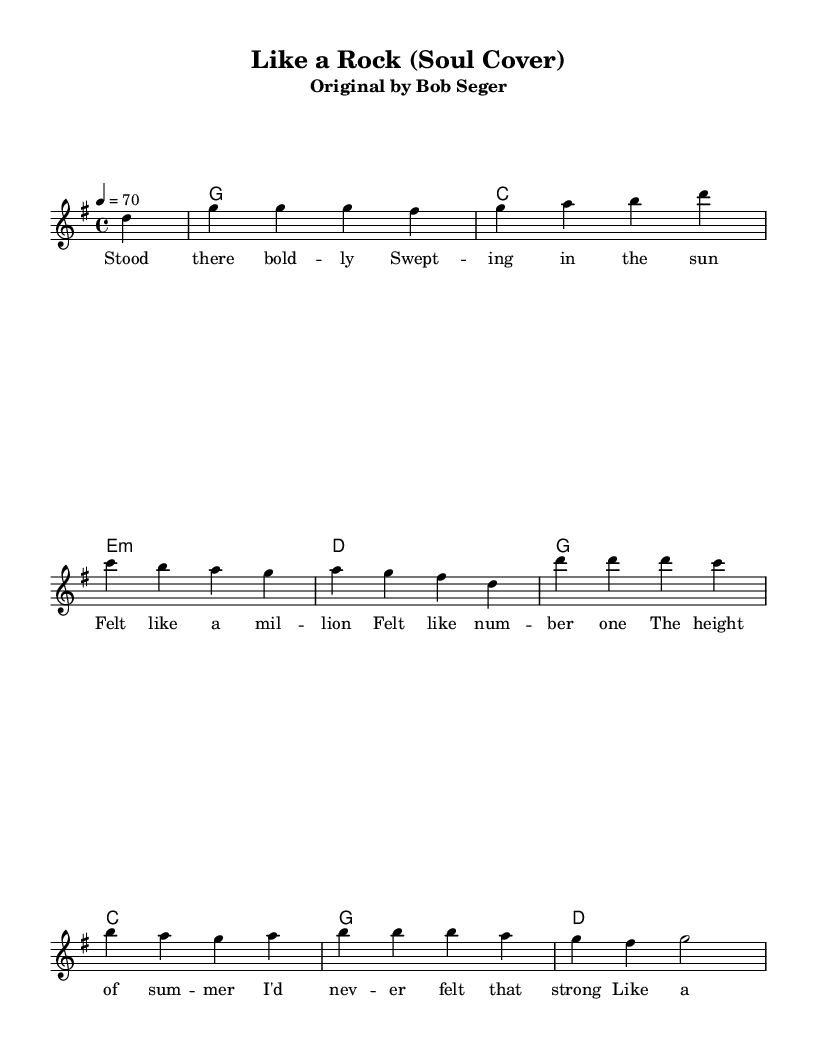What is the key signature of this music? The key signature of this music is G major, which has one sharp (F#). This is determined by the "g" indicated at the beginning of the score.
Answer: G major What is the time signature of this music? The time signature is 4/4, as indicated in the score with the "4/4" shown right after the clef. This means there are four beats per measure.
Answer: 4/4 What is the tempo marking in this piece? The tempo marking is 70 beats per minute, specified as "4 = 70" in the score. This indicates the quarter note is played at a speed of 70 beats per minute.
Answer: 70 How many measures are in the melody section? There are 8 measures in the melody section, which can be counted by identifying the vertical bar lines separating each measure in the melody notation.
Answer: 8 What is the original artist of this song? The original artist is Bob Seger, as noted in the subtitle of the header. This indicates who wrote and originally performed the song being covered.
Answer: Bob Seger What style of music does this piece represent? This piece represents the Soul music genre, as it is described as a "Soul cover" of a classic rock song. This reflects the soulful interpretation of a rock classic.
Answer: Soul 